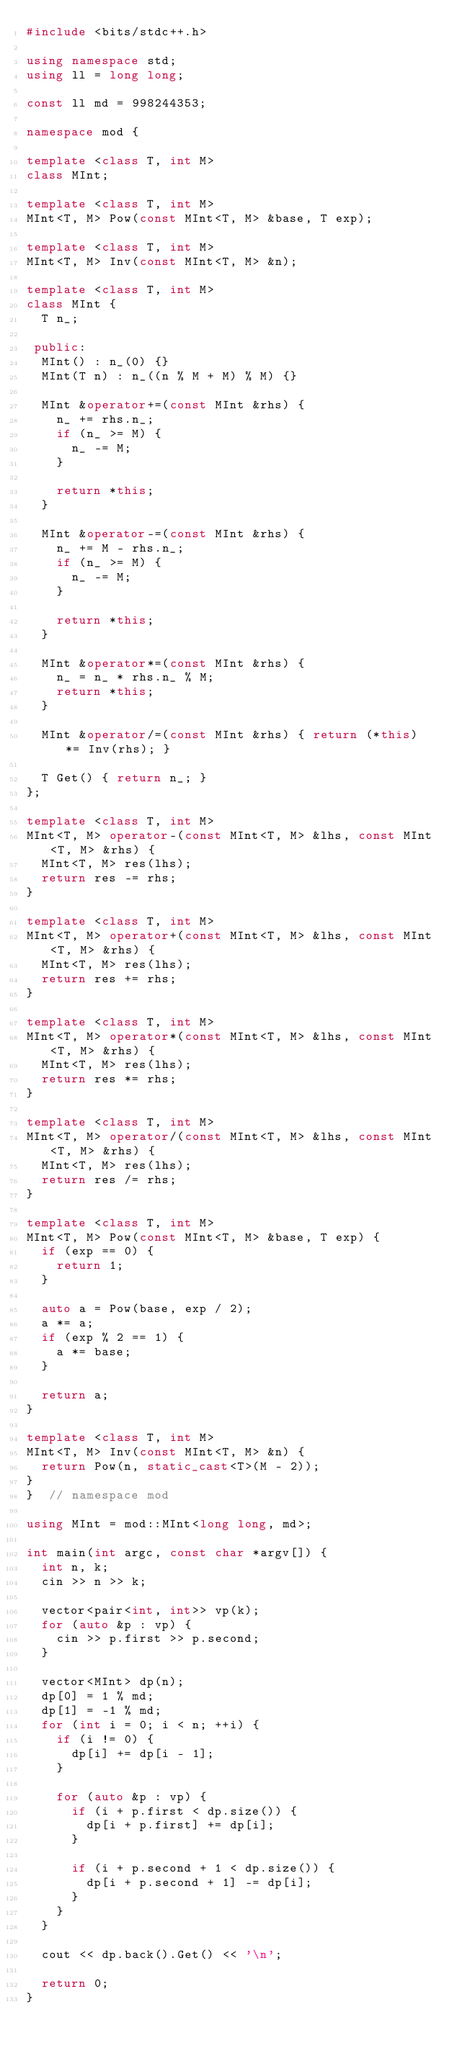<code> <loc_0><loc_0><loc_500><loc_500><_C++_>#include <bits/stdc++.h>

using namespace std;
using ll = long long;

const ll md = 998244353;

namespace mod {

template <class T, int M>
class MInt;

template <class T, int M>
MInt<T, M> Pow(const MInt<T, M> &base, T exp);

template <class T, int M>
MInt<T, M> Inv(const MInt<T, M> &n);

template <class T, int M>
class MInt {
  T n_;

 public:
  MInt() : n_(0) {}
  MInt(T n) : n_((n % M + M) % M) {}

  MInt &operator+=(const MInt &rhs) {
    n_ += rhs.n_;
    if (n_ >= M) {
      n_ -= M;
    }

    return *this;
  }

  MInt &operator-=(const MInt &rhs) {
    n_ += M - rhs.n_;
    if (n_ >= M) {
      n_ -= M;
    }

    return *this;
  }

  MInt &operator*=(const MInt &rhs) {
    n_ = n_ * rhs.n_ % M;
    return *this;
  }

  MInt &operator/=(const MInt &rhs) { return (*this) *= Inv(rhs); }

  T Get() { return n_; }
};

template <class T, int M>
MInt<T, M> operator-(const MInt<T, M> &lhs, const MInt<T, M> &rhs) {
  MInt<T, M> res(lhs);
  return res -= rhs;
}

template <class T, int M>
MInt<T, M> operator+(const MInt<T, M> &lhs, const MInt<T, M> &rhs) {
  MInt<T, M> res(lhs);
  return res += rhs;
}

template <class T, int M>
MInt<T, M> operator*(const MInt<T, M> &lhs, const MInt<T, M> &rhs) {
  MInt<T, M> res(lhs);
  return res *= rhs;
}

template <class T, int M>
MInt<T, M> operator/(const MInt<T, M> &lhs, const MInt<T, M> &rhs) {
  MInt<T, M> res(lhs);
  return res /= rhs;
}

template <class T, int M>
MInt<T, M> Pow(const MInt<T, M> &base, T exp) {
  if (exp == 0) {
    return 1;
  }

  auto a = Pow(base, exp / 2);
  a *= a;
  if (exp % 2 == 1) {
    a *= base;
  }

  return a;
}

template <class T, int M>
MInt<T, M> Inv(const MInt<T, M> &n) {
  return Pow(n, static_cast<T>(M - 2));
}
}  // namespace mod

using MInt = mod::MInt<long long, md>;

int main(int argc, const char *argv[]) {
  int n, k;
  cin >> n >> k;

  vector<pair<int, int>> vp(k);
  for (auto &p : vp) {
    cin >> p.first >> p.second;
  }

  vector<MInt> dp(n);
  dp[0] = 1 % md;
  dp[1] = -1 % md;
  for (int i = 0; i < n; ++i) {
    if (i != 0) {
      dp[i] += dp[i - 1];
    }

    for (auto &p : vp) {
      if (i + p.first < dp.size()) {
        dp[i + p.first] += dp[i];
      }

      if (i + p.second + 1 < dp.size()) {
        dp[i + p.second + 1] -= dp[i];
      }
    }
  }

  cout << dp.back().Get() << '\n';

  return 0;
}</code> 